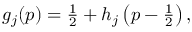Convert formula to latex. <formula><loc_0><loc_0><loc_500><loc_500>\begin{array} { r } { g _ { j } ( p ) = \frac { 1 } { 2 } + h _ { j } \left ( p - \frac { 1 } { 2 } \right ) , } \end{array}</formula> 